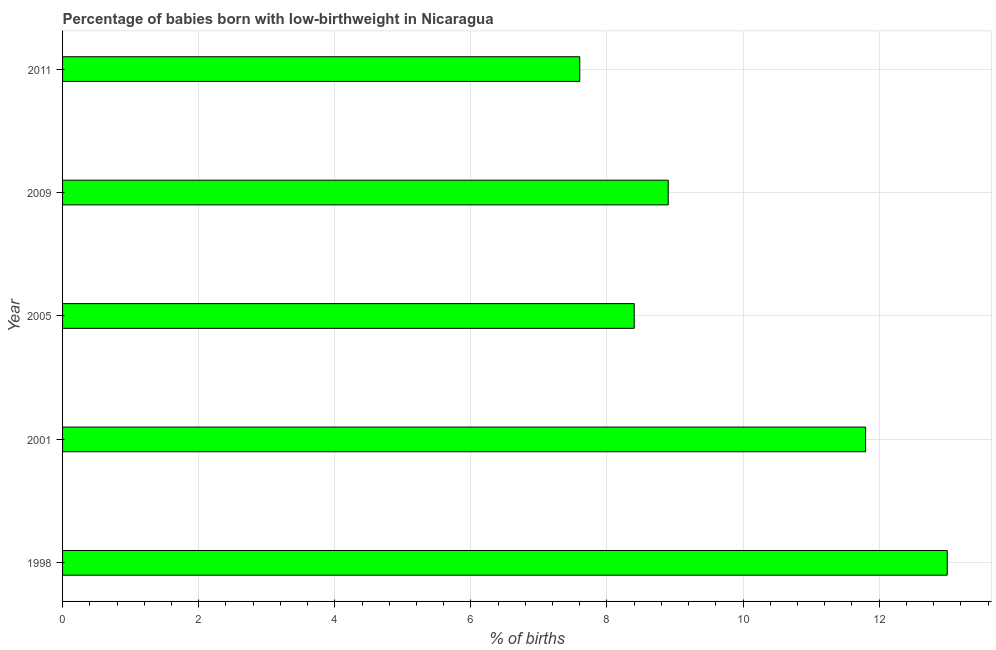Does the graph contain grids?
Keep it short and to the point. Yes. What is the title of the graph?
Make the answer very short. Percentage of babies born with low-birthweight in Nicaragua. What is the label or title of the X-axis?
Offer a terse response. % of births. What is the label or title of the Y-axis?
Provide a short and direct response. Year. What is the percentage of babies who were born with low-birthweight in 1998?
Offer a terse response. 13. Across all years, what is the maximum percentage of babies who were born with low-birthweight?
Provide a succinct answer. 13. Across all years, what is the minimum percentage of babies who were born with low-birthweight?
Your response must be concise. 7.6. In which year was the percentage of babies who were born with low-birthweight minimum?
Ensure brevity in your answer.  2011. What is the sum of the percentage of babies who were born with low-birthweight?
Your answer should be compact. 49.7. What is the difference between the percentage of babies who were born with low-birthweight in 2009 and 2011?
Your answer should be compact. 1.3. What is the average percentage of babies who were born with low-birthweight per year?
Offer a very short reply. 9.94. Do a majority of the years between 2009 and 2005 (inclusive) have percentage of babies who were born with low-birthweight greater than 6.8 %?
Make the answer very short. No. What is the ratio of the percentage of babies who were born with low-birthweight in 2005 to that in 2011?
Your response must be concise. 1.1. Is the percentage of babies who were born with low-birthweight in 2005 less than that in 2011?
Provide a succinct answer. No. Is the sum of the percentage of babies who were born with low-birthweight in 2001 and 2011 greater than the maximum percentage of babies who were born with low-birthweight across all years?
Keep it short and to the point. Yes. How many bars are there?
Provide a short and direct response. 5. Are the values on the major ticks of X-axis written in scientific E-notation?
Keep it short and to the point. No. What is the % of births of 1998?
Give a very brief answer. 13. What is the % of births in 2001?
Give a very brief answer. 11.8. What is the difference between the % of births in 1998 and 2001?
Your answer should be very brief. 1.2. What is the difference between the % of births in 1998 and 2005?
Your answer should be compact. 4.6. What is the difference between the % of births in 1998 and 2009?
Offer a terse response. 4.1. What is the difference between the % of births in 1998 and 2011?
Offer a terse response. 5.4. What is the difference between the % of births in 2001 and 2005?
Your answer should be compact. 3.4. What is the difference between the % of births in 2001 and 2009?
Offer a very short reply. 2.9. What is the difference between the % of births in 2005 and 2009?
Offer a terse response. -0.5. What is the difference between the % of births in 2009 and 2011?
Your answer should be very brief. 1.3. What is the ratio of the % of births in 1998 to that in 2001?
Your answer should be very brief. 1.1. What is the ratio of the % of births in 1998 to that in 2005?
Provide a short and direct response. 1.55. What is the ratio of the % of births in 1998 to that in 2009?
Keep it short and to the point. 1.46. What is the ratio of the % of births in 1998 to that in 2011?
Make the answer very short. 1.71. What is the ratio of the % of births in 2001 to that in 2005?
Provide a succinct answer. 1.41. What is the ratio of the % of births in 2001 to that in 2009?
Your answer should be compact. 1.33. What is the ratio of the % of births in 2001 to that in 2011?
Offer a very short reply. 1.55. What is the ratio of the % of births in 2005 to that in 2009?
Make the answer very short. 0.94. What is the ratio of the % of births in 2005 to that in 2011?
Provide a succinct answer. 1.1. What is the ratio of the % of births in 2009 to that in 2011?
Keep it short and to the point. 1.17. 